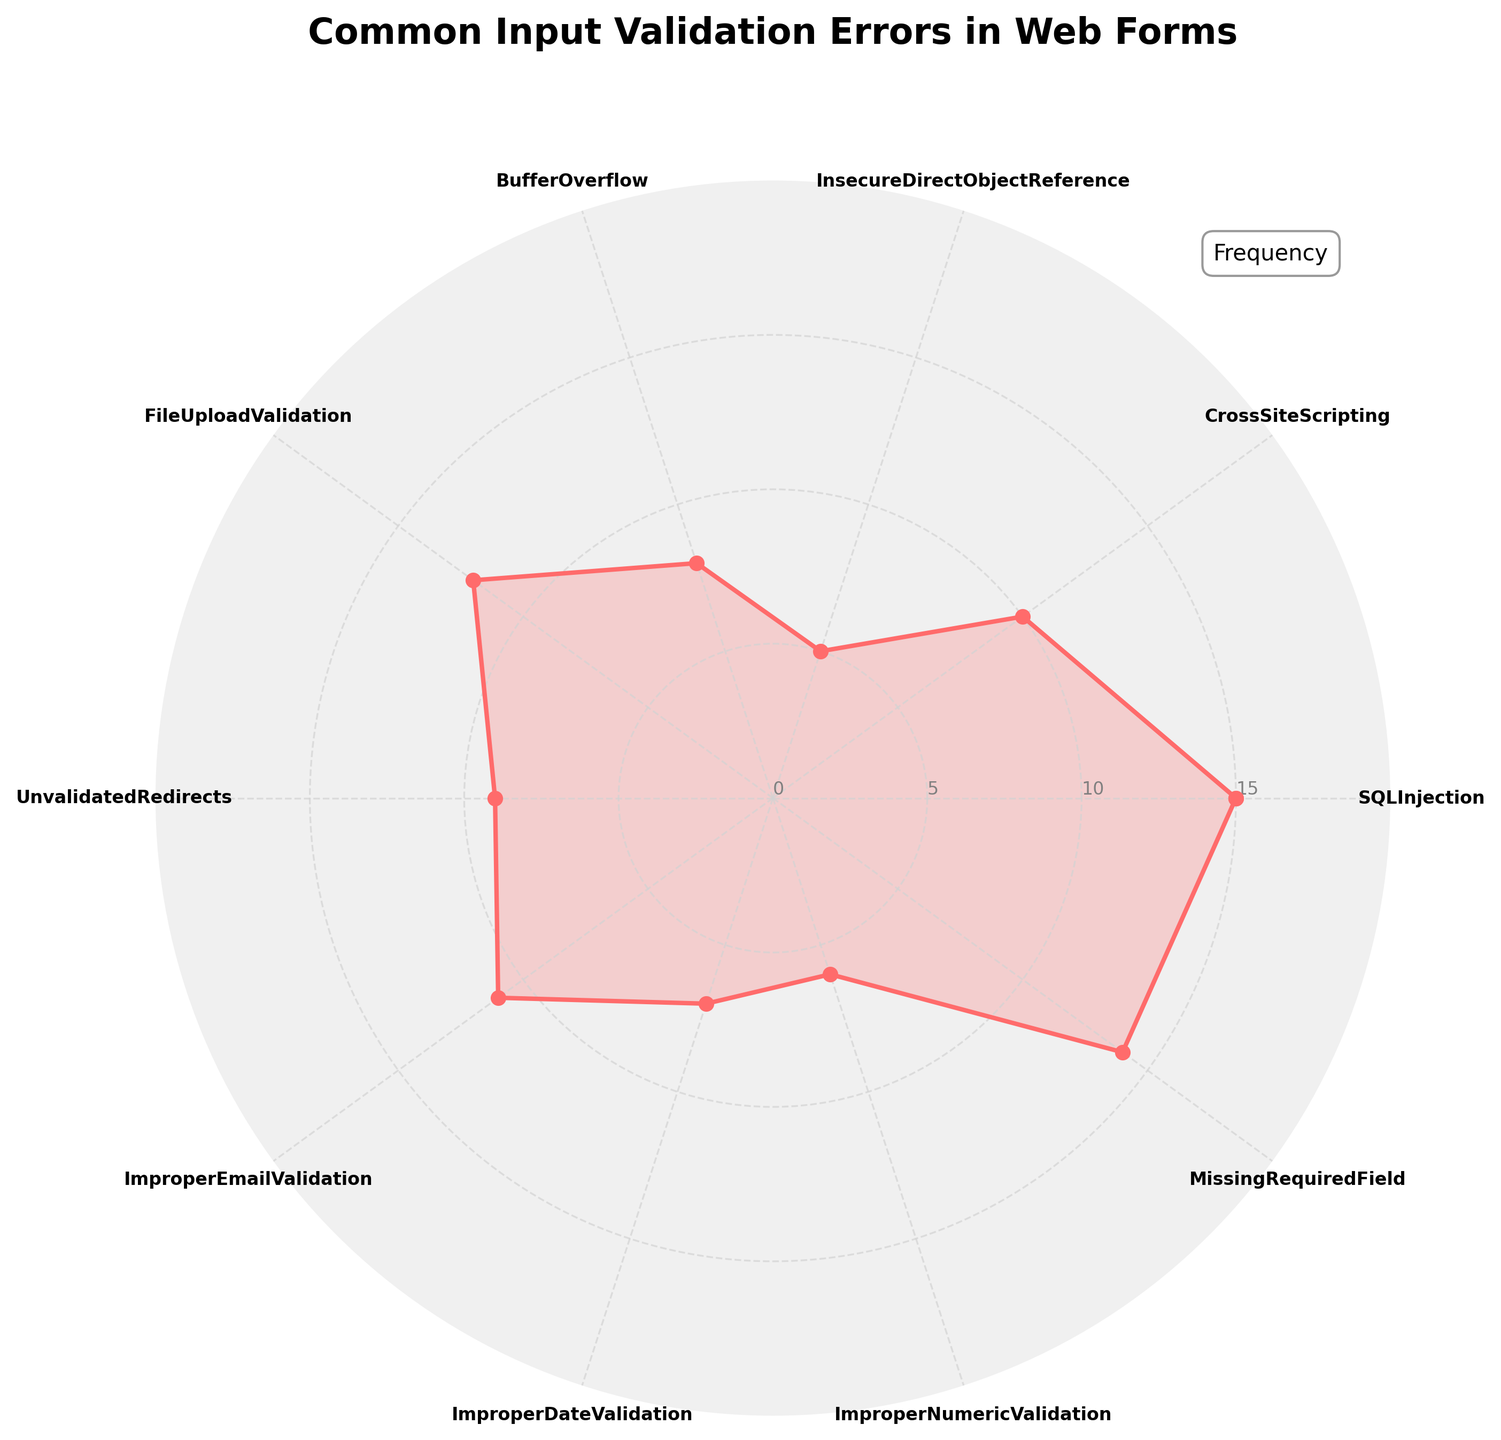What's the title of the chart? The title of the chart is displayed prominently at the top of the chart.
Answer: Common Input Validation Errors in Web Forms What is the highest frequency error and what is its value? Identify the error with the largest value among the data points. The error with the highest frequency is represented by the tallest point in the filled area.
Answer: SQLInjection, 15 Which input validation error has the second highest frequency? By examining the lengths of each data point visually, identify the error with the second-largest value.
Answer: MissingRequiredField, 14 What is the combined frequency of BufferOverflow and ImproperEmailValidation? Sum the frequency values of BufferOverflow (8) and ImproperEmailValidation (11) to get the combined frequency.
Answer: 8 + 11 = 19 How many input validation errors have a frequency greater than 10? Count the number of data points with values exceeding 10. The errors are SQLInjection (15), MissingRequiredField (14), FileUploadValidation (12), and ImproperEmailValidation (11).
Answer: 4 Which input validation error has the lowest frequency? Identify the error associated with the smallest value among the data points. The error with the smallest frequency is represented by the shortest point in the filled area.
Answer: InsecureDirectObjectReference, 5 What is the frequency difference between CrossSiteScripting and ImproperDateValidation? Subtract the frequency of ImproperDateValidation (7) from CrossSiteScripting (10).
Answer: 10 - 7 = 3 What is the average frequency of all the input validation errors? Sum all frequency values and divide by the number of data points. (15+10+5+8+12+9+11+7+6+14) / 10.
Answer: 97 / 10 = 9.7 Between FileUploadValidation and UnvalidatedRedirects, which has a higher frequency and by how much? Compare the frequencies of FileUploadValidation (12) and UnvalidatedRedirects (9), then determine the difference.
Answer: FileUploadValidation, 3 On average, are validation errors more or less frequent than 10? Compare the calculated average frequency of all errors to 10. The average frequency calculated is 9.7, which is less than 10.
Answer: Less frequent 